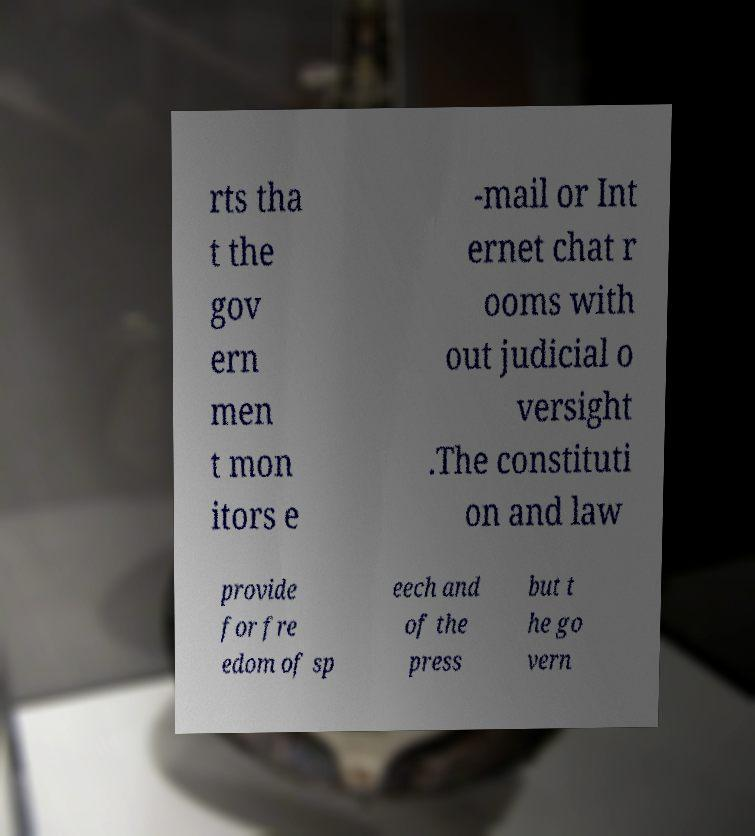Please identify and transcribe the text found in this image. rts tha t the gov ern men t mon itors e -mail or Int ernet chat r ooms with out judicial o versight .The constituti on and law provide for fre edom of sp eech and of the press but t he go vern 